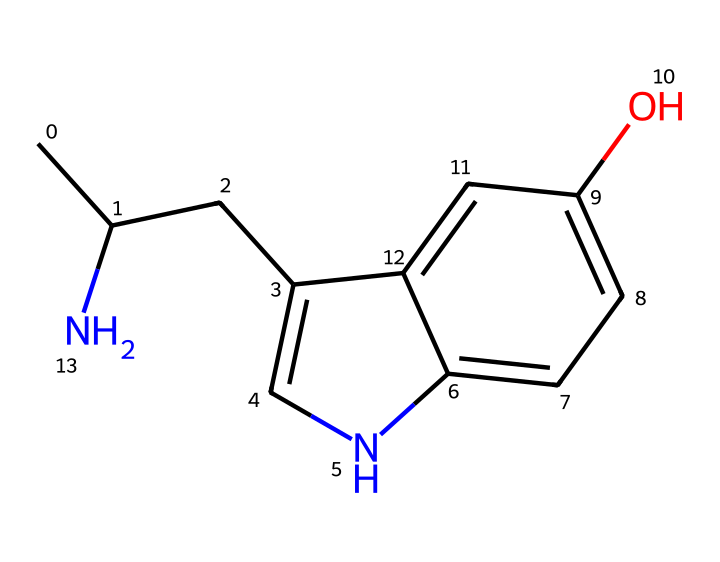What is the primary element present in this chemical structure? The chemical contains multiple elements, but the most abundant one is carbon, which forms the backbone of the structure.
Answer: carbon How many nitrogen atoms are in the structure? The SMILES representation shows one nitrogen atom in the ring structure, as indicated by the letter "N."
Answer: 1 What type of functional group is present in this chemical? Looking at the structure, there is a hydroxyl (-OH) group present, which is indicated by the "O" in the SMILES notation, showing it as a phenolic compound.
Answer: hydroxyl Is this compound typically classified as a stimulant or a depressant? Serotonin is known to be a neurotransmitter that can elevate mood, indicating that it has stimulant-like properties, promoting feelings of well-being and happiness.
Answer: stimulant What is the molecular formula of this compound? By analyzing the SMILES and counting all the carbon, hydrogen, nitrogen, and oxygen atoms, you can derive the molecular formula, which is C12H15N1O1.
Answer: C12H15N1O1 